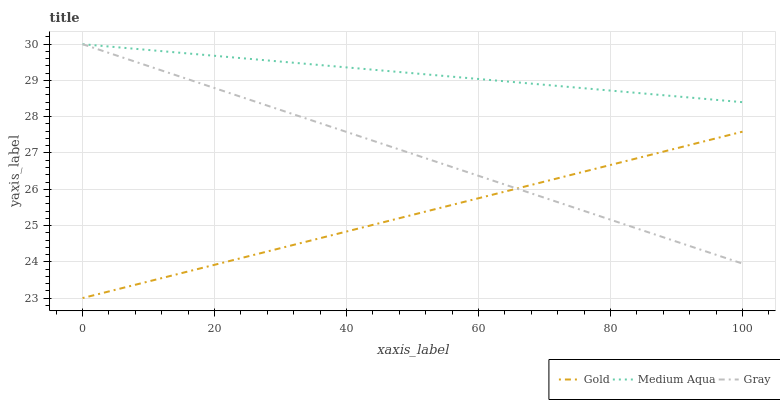Does Medium Aqua have the minimum area under the curve?
Answer yes or no. No. Does Gold have the maximum area under the curve?
Answer yes or no. No. Is Gold the smoothest?
Answer yes or no. No. Is Gold the roughest?
Answer yes or no. No. Does Medium Aqua have the lowest value?
Answer yes or no. No. Does Gold have the highest value?
Answer yes or no. No. Is Gold less than Medium Aqua?
Answer yes or no. Yes. Is Medium Aqua greater than Gold?
Answer yes or no. Yes. Does Gold intersect Medium Aqua?
Answer yes or no. No. 